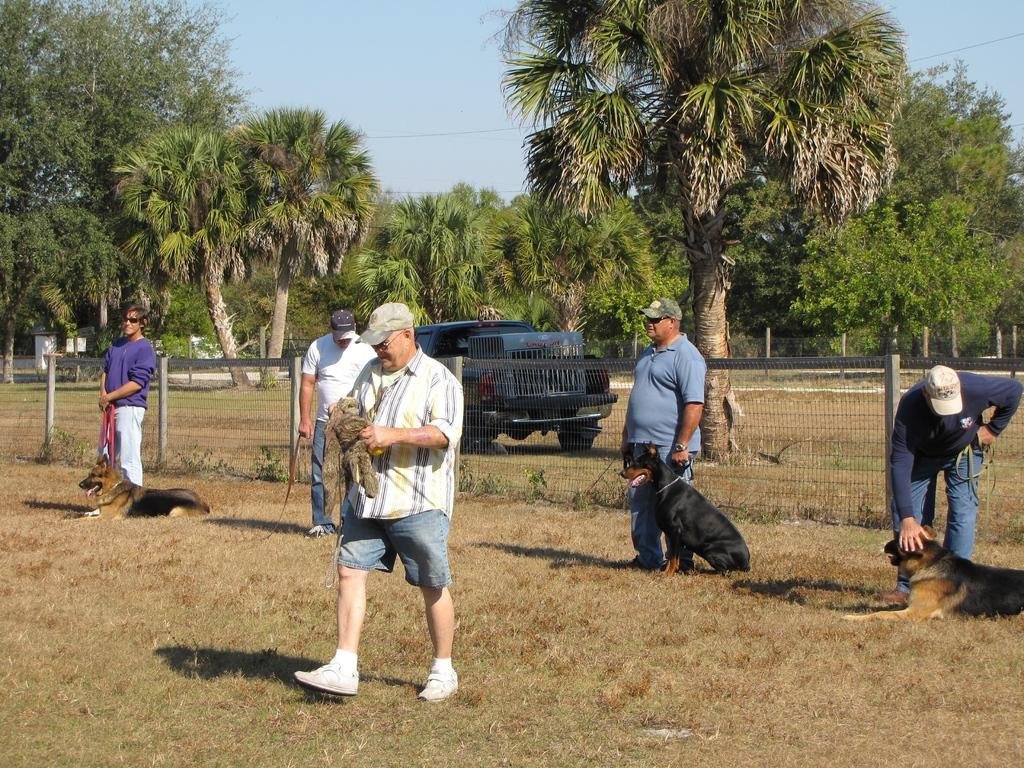What types of living beings are present in the image? There are people and dogs in the image. What type of natural environment is visible in the image? There are trees and grass in the image. What man-made object can be seen in the image? There is a vehicle in the image. What type of barrier is present in the image? There is fencing in the image. What part of the natural environment is visible in the background of the image? The sky is visible in the background of the image. What type of silver coil can be seen powering the vehicle in the image? There is no silver coil present in the image, nor is there any indication of a power source for the vehicle. 